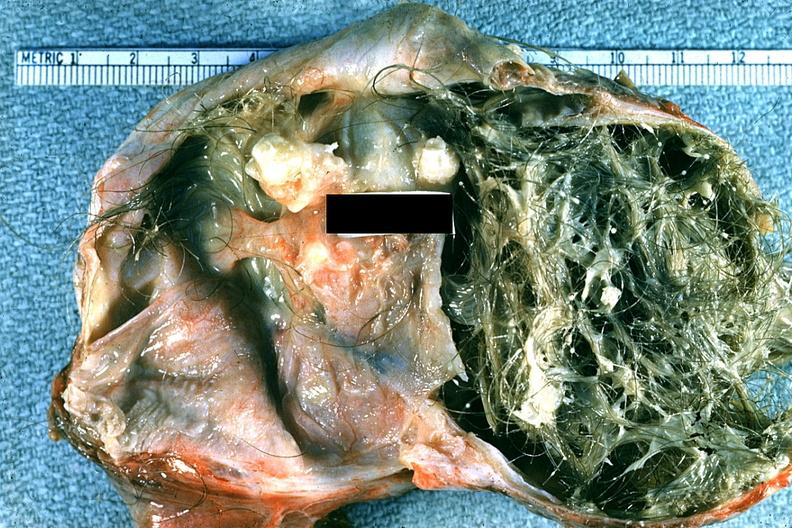s capillary present?
Answer the question using a single word or phrase. No 